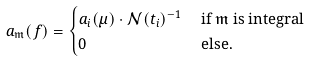Convert formula to latex. <formula><loc_0><loc_0><loc_500><loc_500>a _ { \mathfrak { m } } ( { f } ) & = \begin{cases} a _ { i } ( \mu ) \cdot \mathcal { N } ( t _ { i } ) ^ { - 1 } & \text { if $\mathfrak{m}$ is integral} \\ 0 & \text { else} . \end{cases}</formula> 